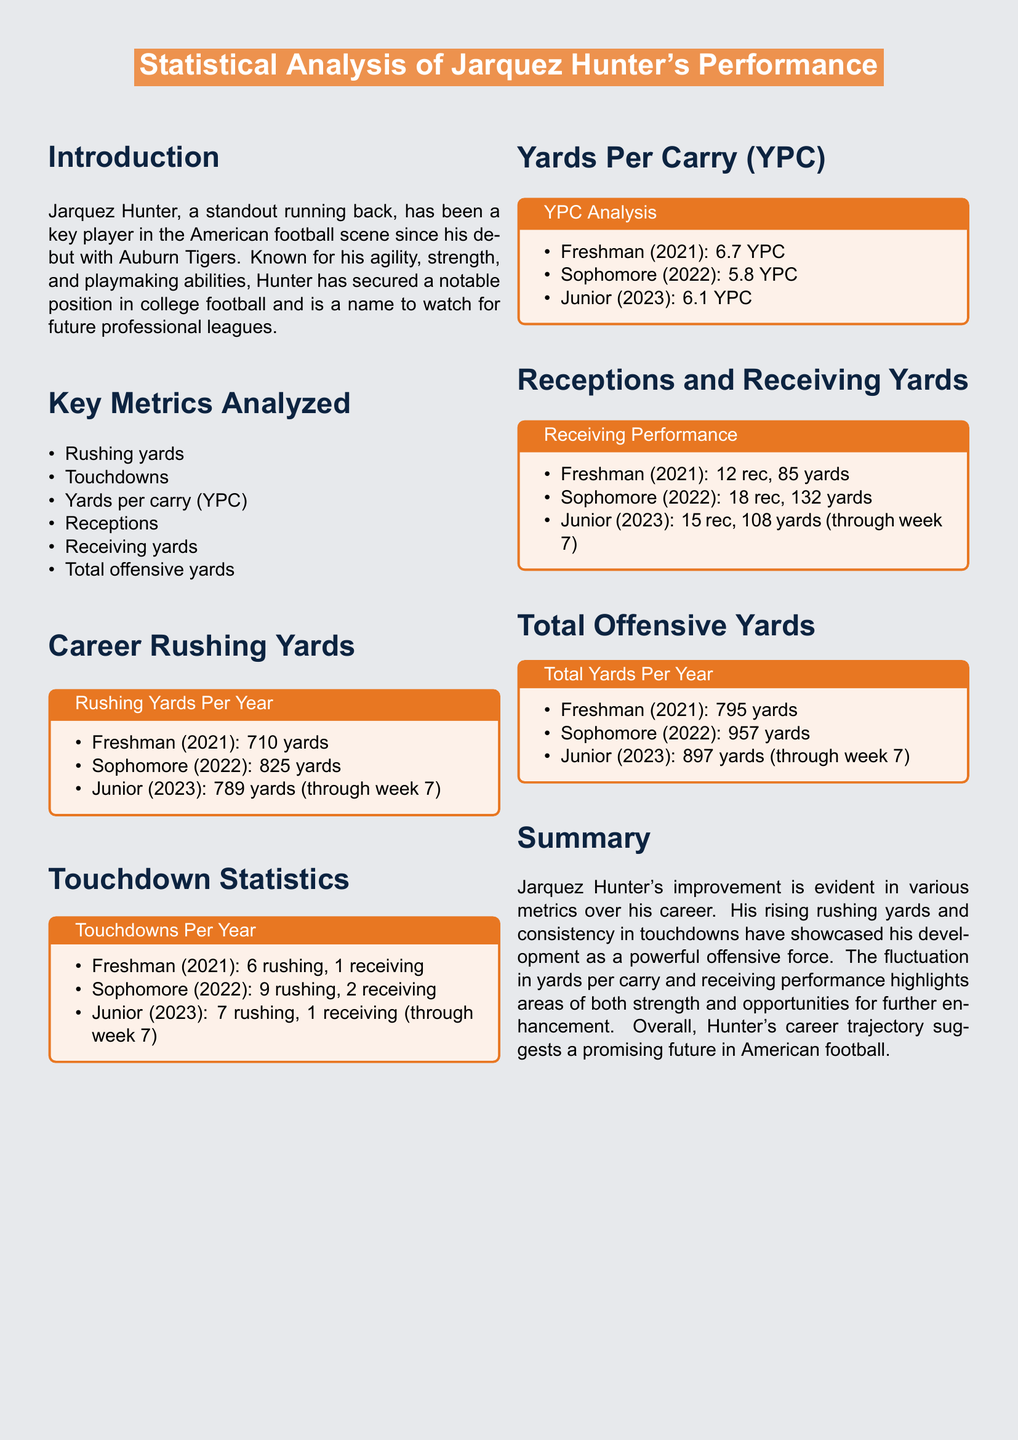What were Jarquez Hunter's rushing yards as a sophomore? The document lists the rushing yards over the years, noting that he had 825 yards during his sophomore year in 2022.
Answer: 825 yards How many touchdowns did Jarquez Hunter score in his freshman year? According to the touchdown statistics, he scored 6 rushing and 1 receiving touchdown, totaling 7.
Answer: 7 What is Jarquez Hunter's average yards per carry in 2021? The YPC analysis mentions that in his freshman year, he averaged 6.7 yards per carry.
Answer: 6.7 YPC How many total offensive yards did Jarquez Hunter accumulate by the end of his sophomore year? The total offensive yards section states that he had 957 yards at the conclusion of his sophomore year.
Answer: 957 yards Which year did Jarquez Hunter have the highest total offensive yards? The summary of total offensive yards indicates that his best year for total yards was during his sophomore year with 957.
Answer: Sophomore (2022) In which year did Jarquez Hunter record the most receptions? From the receiving performance data, it's noted that he had 18 receptions during his sophomore year.
Answer: Sophomore (2022) What was the number of receiving yards for Jarquez Hunter as a junior through week 7? The receiving performance mentions 108 receiving yards for his junior year up to week 7.
Answer: 108 yards How has Jarquez Hunter's rushing yards changed from his freshman to junior year? The document's career rushing yards section shows an increase from 710 to 789 yards, showing he initially improved and then dropped slightly.
Answer: Increased then dropped What overall trend does the summary suggest about Jarquez Hunter's performance? The summary highlights Hunter's improvement over time, particularly in rushing yards and touchdowns, suggesting a promising future.
Answer: Promising future 